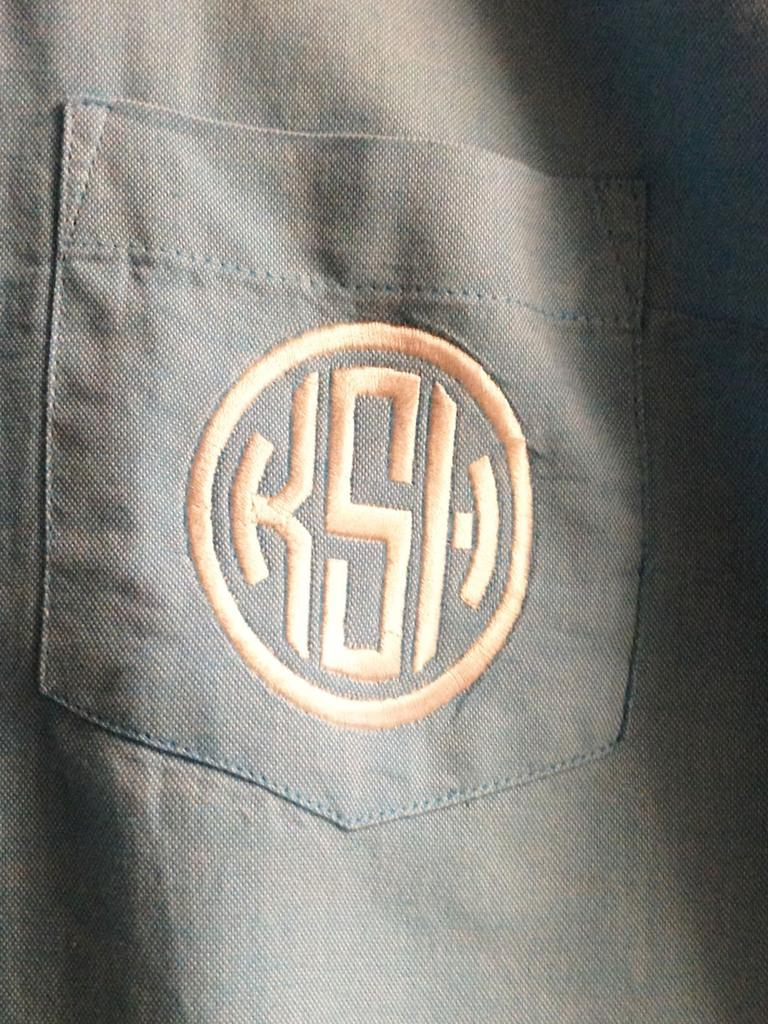What is the main subject of the image? The main subject of the image is a pocket of a shirt. Where is the pocket located on the shirt? The pocket is in the center of the image. How much sugar is in the pocket of the shirt in the image? There is no sugar present in the pocket of the shirt in the image. 